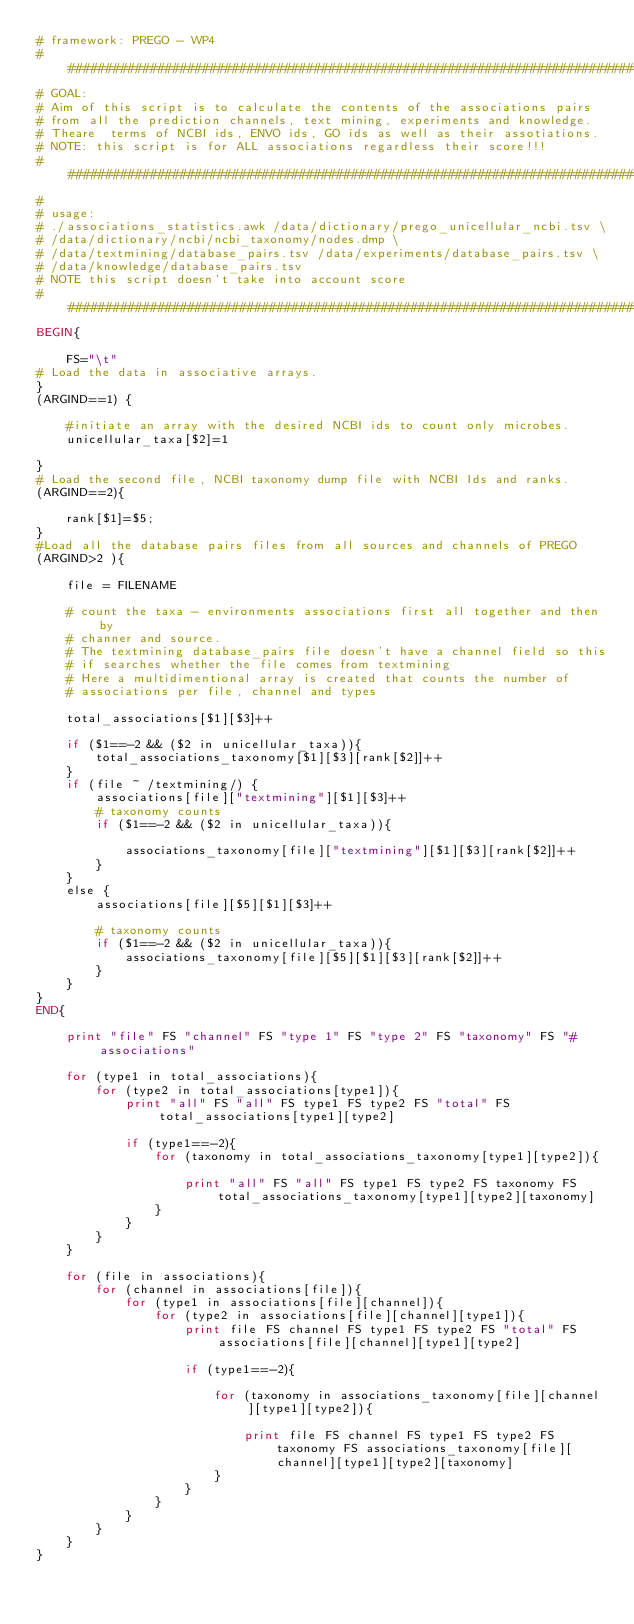Convert code to text. <code><loc_0><loc_0><loc_500><loc_500><_Awk_># framework: PREGO - WP4
###############################################################################
# GOAL:
# Aim of this script is to calculate the contents of the associations pairs 
# from all the prediction channels, text mining, experiments and knowledge.
# Theare  terms of NCBI ids, ENVO ids, GO ids as well as their assotiations.
# NOTE: this script is for ALL associations regardless their score!!!
###############################################################################
#
# usage:
# ./associations_statistics.awk /data/dictionary/prego_unicellular_ncbi.tsv \
# /data/dictionary/ncbi/ncbi_taxonomy/nodes.dmp \
# /data/textmining/database_pairs.tsv /data/experiments/database_pairs.tsv \
# /data/knowledge/database_pairs.tsv
# NOTE this script doesn't take into account score
###############################################################################
BEGIN{

    FS="\t"
# Load the data in associative arrays.
}
(ARGIND==1) {

    #initiate an array with the desired NCBI ids to count only microbes.
    unicellular_taxa[$2]=1

}
# Load the second file, NCBI taxonomy dump file with NCBI Ids and ranks.
(ARGIND==2){

    rank[$1]=$5;
}
#Load all the database pairs files from all sources and channels of PREGO
(ARGIND>2 ){

    file = FILENAME
    
    # count the taxa - environments associations first all together and then by
    # channer and source.
    # The textmining database_pairs file doesn't have a channel field so this
    # if searches whether the file comes from textmining 
    # Here a multidimentional array is created that counts the number of 
    # associations per file, channel and types

    total_associations[$1][$3]++
    
    if ($1==-2 && ($2 in unicellular_taxa)){
        total_associations_taxonomy[$1][$3][rank[$2]]++
    }
    if (file ~ /textmining/) {
        associations[file]["textmining"][$1][$3]++
        # taxonomy counts
        if ($1==-2 && ($2 in unicellular_taxa)){

            associations_taxonomy[file]["textmining"][$1][$3][rank[$2]]++
        }
    }
    else {
        associations[file][$5][$1][$3]++
        
        # taxonomy counts
        if ($1==-2 && ($2 in unicellular_taxa)){
            associations_taxonomy[file][$5][$1][$3][rank[$2]]++
        }
    }
}
END{

    print "file" FS "channel" FS "type 1" FS "type 2" FS "taxonomy" FS "# associations"

    for (type1 in total_associations){
        for (type2 in total_associations[type1]){
            print "all" FS "all" FS type1 FS type2 FS "total" FS total_associations[type1][type2]

            if (type1==-2){
                for (taxonomy in total_associations_taxonomy[type1][type2]){

                    print "all" FS "all" FS type1 FS type2 FS taxonomy FS total_associations_taxonomy[type1][type2][taxonomy]
                }
            }
        }
    }

    for (file in associations){
        for (channel in associations[file]){
            for (type1 in associations[file][channel]){
                for (type2 in associations[file][channel][type1]){
                    print file FS channel FS type1 FS type2 FS "total" FS associations[file][channel][type1][type2]

                    if (type1==-2){

                        for (taxonomy in associations_taxonomy[file][channel][type1][type2]){

                            print file FS channel FS type1 FS type2 FS taxonomy FS associations_taxonomy[file][channel][type1][type2][taxonomy]
                        }
                    }
                }
            }
        }
    }
}

</code> 